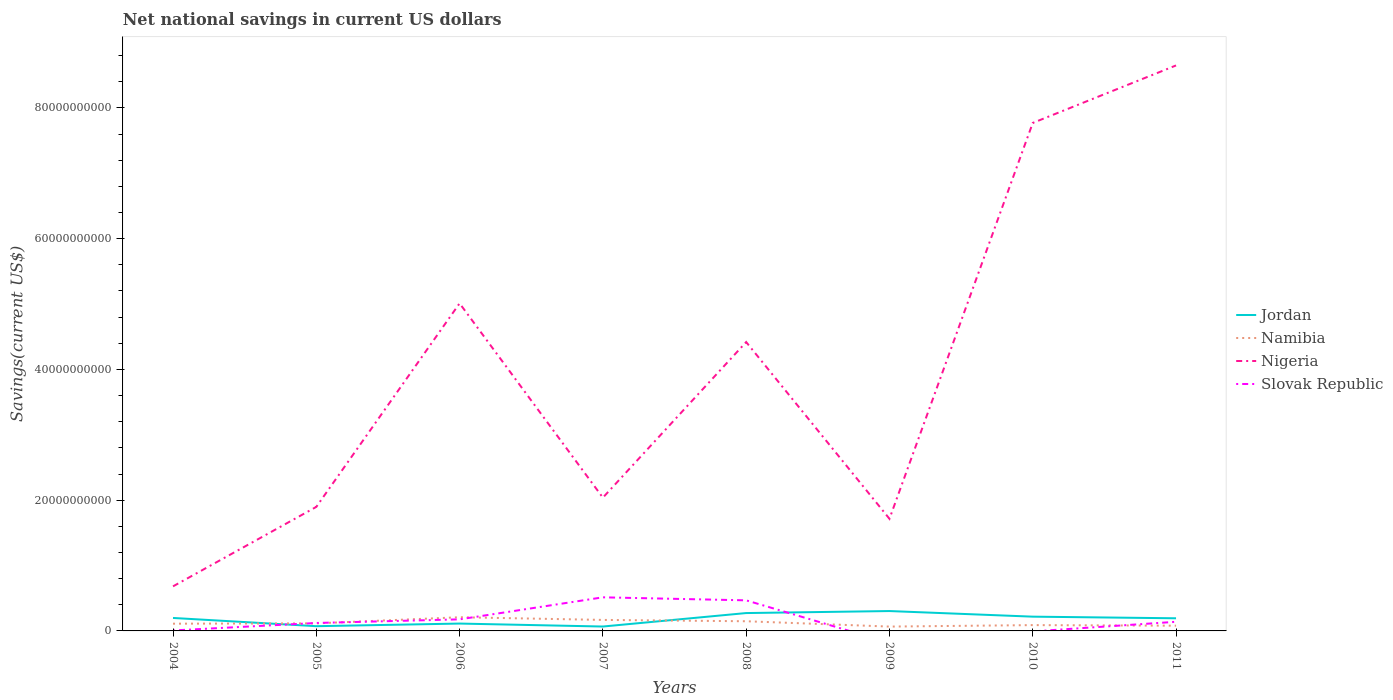Does the line corresponding to Jordan intersect with the line corresponding to Nigeria?
Offer a terse response. No. What is the total net national savings in Namibia in the graph?
Your response must be concise. -4.90e+07. What is the difference between the highest and the second highest net national savings in Slovak Republic?
Your answer should be very brief. 5.14e+09. What is the difference between the highest and the lowest net national savings in Slovak Republic?
Your answer should be very brief. 2. How many lines are there?
Keep it short and to the point. 4. Does the graph contain grids?
Provide a succinct answer. No. Where does the legend appear in the graph?
Provide a succinct answer. Center right. How many legend labels are there?
Keep it short and to the point. 4. How are the legend labels stacked?
Your response must be concise. Vertical. What is the title of the graph?
Offer a terse response. Net national savings in current US dollars. Does "Bahamas" appear as one of the legend labels in the graph?
Your response must be concise. No. What is the label or title of the Y-axis?
Offer a very short reply. Savings(current US$). What is the Savings(current US$) in Jordan in 2004?
Your response must be concise. 1.98e+09. What is the Savings(current US$) in Namibia in 2004?
Your response must be concise. 1.11e+09. What is the Savings(current US$) of Nigeria in 2004?
Your response must be concise. 6.82e+09. What is the Savings(current US$) in Slovak Republic in 2004?
Offer a very short reply. 6.97e+07. What is the Savings(current US$) in Jordan in 2005?
Offer a very short reply. 7.24e+08. What is the Savings(current US$) of Namibia in 2005?
Your answer should be compact. 1.16e+09. What is the Savings(current US$) of Nigeria in 2005?
Your response must be concise. 1.90e+1. What is the Savings(current US$) in Slovak Republic in 2005?
Your answer should be very brief. 1.21e+09. What is the Savings(current US$) in Jordan in 2006?
Your response must be concise. 1.13e+09. What is the Savings(current US$) in Namibia in 2006?
Your answer should be very brief. 2.09e+09. What is the Savings(current US$) in Nigeria in 2006?
Provide a succinct answer. 5.01e+1. What is the Savings(current US$) of Slovak Republic in 2006?
Provide a succinct answer. 1.77e+09. What is the Savings(current US$) of Jordan in 2007?
Offer a terse response. 6.72e+08. What is the Savings(current US$) in Namibia in 2007?
Provide a short and direct response. 1.68e+09. What is the Savings(current US$) in Nigeria in 2007?
Give a very brief answer. 2.04e+1. What is the Savings(current US$) of Slovak Republic in 2007?
Your answer should be very brief. 5.14e+09. What is the Savings(current US$) of Jordan in 2008?
Give a very brief answer. 2.73e+09. What is the Savings(current US$) in Namibia in 2008?
Offer a very short reply. 1.48e+09. What is the Savings(current US$) in Nigeria in 2008?
Provide a short and direct response. 4.42e+1. What is the Savings(current US$) in Slovak Republic in 2008?
Provide a succinct answer. 4.68e+09. What is the Savings(current US$) in Jordan in 2009?
Offer a very short reply. 3.04e+09. What is the Savings(current US$) of Namibia in 2009?
Give a very brief answer. 6.64e+08. What is the Savings(current US$) of Nigeria in 2009?
Offer a very short reply. 1.72e+1. What is the Savings(current US$) of Jordan in 2010?
Ensure brevity in your answer.  2.18e+09. What is the Savings(current US$) of Namibia in 2010?
Offer a terse response. 8.89e+08. What is the Savings(current US$) in Nigeria in 2010?
Your answer should be very brief. 7.77e+1. What is the Savings(current US$) of Jordan in 2011?
Ensure brevity in your answer.  1.93e+09. What is the Savings(current US$) of Namibia in 2011?
Provide a short and direct response. 8.00e+08. What is the Savings(current US$) in Nigeria in 2011?
Your answer should be compact. 8.65e+1. What is the Savings(current US$) in Slovak Republic in 2011?
Keep it short and to the point. 1.40e+09. Across all years, what is the maximum Savings(current US$) in Jordan?
Provide a succinct answer. 3.04e+09. Across all years, what is the maximum Savings(current US$) in Namibia?
Keep it short and to the point. 2.09e+09. Across all years, what is the maximum Savings(current US$) of Nigeria?
Provide a succinct answer. 8.65e+1. Across all years, what is the maximum Savings(current US$) in Slovak Republic?
Offer a terse response. 5.14e+09. Across all years, what is the minimum Savings(current US$) of Jordan?
Ensure brevity in your answer.  6.72e+08. Across all years, what is the minimum Savings(current US$) in Namibia?
Keep it short and to the point. 6.64e+08. Across all years, what is the minimum Savings(current US$) in Nigeria?
Your answer should be very brief. 6.82e+09. Across all years, what is the minimum Savings(current US$) in Slovak Republic?
Ensure brevity in your answer.  0. What is the total Savings(current US$) of Jordan in the graph?
Ensure brevity in your answer.  1.44e+1. What is the total Savings(current US$) in Namibia in the graph?
Ensure brevity in your answer.  9.87e+09. What is the total Savings(current US$) of Nigeria in the graph?
Keep it short and to the point. 3.22e+11. What is the total Savings(current US$) of Slovak Republic in the graph?
Your answer should be compact. 1.43e+1. What is the difference between the Savings(current US$) of Jordan in 2004 and that in 2005?
Your answer should be compact. 1.26e+09. What is the difference between the Savings(current US$) in Namibia in 2004 and that in 2005?
Your answer should be compact. -4.90e+07. What is the difference between the Savings(current US$) of Nigeria in 2004 and that in 2005?
Provide a succinct answer. -1.22e+1. What is the difference between the Savings(current US$) of Slovak Republic in 2004 and that in 2005?
Offer a terse response. -1.14e+09. What is the difference between the Savings(current US$) of Jordan in 2004 and that in 2006?
Keep it short and to the point. 8.58e+08. What is the difference between the Savings(current US$) in Namibia in 2004 and that in 2006?
Provide a short and direct response. -9.87e+08. What is the difference between the Savings(current US$) in Nigeria in 2004 and that in 2006?
Ensure brevity in your answer.  -4.33e+1. What is the difference between the Savings(current US$) in Slovak Republic in 2004 and that in 2006?
Keep it short and to the point. -1.70e+09. What is the difference between the Savings(current US$) in Jordan in 2004 and that in 2007?
Ensure brevity in your answer.  1.31e+09. What is the difference between the Savings(current US$) of Namibia in 2004 and that in 2007?
Keep it short and to the point. -5.77e+08. What is the difference between the Savings(current US$) of Nigeria in 2004 and that in 2007?
Your answer should be compact. -1.36e+1. What is the difference between the Savings(current US$) in Slovak Republic in 2004 and that in 2007?
Ensure brevity in your answer.  -5.07e+09. What is the difference between the Savings(current US$) in Jordan in 2004 and that in 2008?
Your answer should be very brief. -7.50e+08. What is the difference between the Savings(current US$) in Namibia in 2004 and that in 2008?
Your answer should be compact. -3.73e+08. What is the difference between the Savings(current US$) of Nigeria in 2004 and that in 2008?
Give a very brief answer. -3.74e+1. What is the difference between the Savings(current US$) in Slovak Republic in 2004 and that in 2008?
Keep it short and to the point. -4.61e+09. What is the difference between the Savings(current US$) of Jordan in 2004 and that in 2009?
Keep it short and to the point. -1.06e+09. What is the difference between the Savings(current US$) in Namibia in 2004 and that in 2009?
Offer a terse response. 4.42e+08. What is the difference between the Savings(current US$) in Nigeria in 2004 and that in 2009?
Your answer should be very brief. -1.03e+1. What is the difference between the Savings(current US$) of Jordan in 2004 and that in 2010?
Give a very brief answer. -2.00e+08. What is the difference between the Savings(current US$) in Namibia in 2004 and that in 2010?
Provide a short and direct response. 2.17e+08. What is the difference between the Savings(current US$) of Nigeria in 2004 and that in 2010?
Your response must be concise. -7.09e+1. What is the difference between the Savings(current US$) in Jordan in 2004 and that in 2011?
Offer a very short reply. 4.93e+07. What is the difference between the Savings(current US$) of Namibia in 2004 and that in 2011?
Your answer should be very brief. 3.07e+08. What is the difference between the Savings(current US$) in Nigeria in 2004 and that in 2011?
Your response must be concise. -7.97e+1. What is the difference between the Savings(current US$) in Slovak Republic in 2004 and that in 2011?
Make the answer very short. -1.33e+09. What is the difference between the Savings(current US$) of Jordan in 2005 and that in 2006?
Offer a terse response. -4.02e+08. What is the difference between the Savings(current US$) of Namibia in 2005 and that in 2006?
Your answer should be very brief. -9.38e+08. What is the difference between the Savings(current US$) of Nigeria in 2005 and that in 2006?
Make the answer very short. -3.11e+1. What is the difference between the Savings(current US$) in Slovak Republic in 2005 and that in 2006?
Offer a very short reply. -5.56e+08. What is the difference between the Savings(current US$) in Jordan in 2005 and that in 2007?
Offer a terse response. 5.21e+07. What is the difference between the Savings(current US$) in Namibia in 2005 and that in 2007?
Provide a succinct answer. -5.28e+08. What is the difference between the Savings(current US$) in Nigeria in 2005 and that in 2007?
Offer a very short reply. -1.41e+09. What is the difference between the Savings(current US$) in Slovak Republic in 2005 and that in 2007?
Your response must be concise. -3.92e+09. What is the difference between the Savings(current US$) of Jordan in 2005 and that in 2008?
Make the answer very short. -2.01e+09. What is the difference between the Savings(current US$) of Namibia in 2005 and that in 2008?
Provide a succinct answer. -3.24e+08. What is the difference between the Savings(current US$) in Nigeria in 2005 and that in 2008?
Make the answer very short. -2.52e+1. What is the difference between the Savings(current US$) in Slovak Republic in 2005 and that in 2008?
Ensure brevity in your answer.  -3.46e+09. What is the difference between the Savings(current US$) in Jordan in 2005 and that in 2009?
Ensure brevity in your answer.  -2.32e+09. What is the difference between the Savings(current US$) in Namibia in 2005 and that in 2009?
Offer a terse response. 4.91e+08. What is the difference between the Savings(current US$) in Nigeria in 2005 and that in 2009?
Provide a succinct answer. 1.82e+09. What is the difference between the Savings(current US$) in Jordan in 2005 and that in 2010?
Make the answer very short. -1.46e+09. What is the difference between the Savings(current US$) in Namibia in 2005 and that in 2010?
Your response must be concise. 2.66e+08. What is the difference between the Savings(current US$) in Nigeria in 2005 and that in 2010?
Offer a terse response. -5.87e+1. What is the difference between the Savings(current US$) of Jordan in 2005 and that in 2011?
Give a very brief answer. -1.21e+09. What is the difference between the Savings(current US$) in Namibia in 2005 and that in 2011?
Your answer should be compact. 3.56e+08. What is the difference between the Savings(current US$) of Nigeria in 2005 and that in 2011?
Give a very brief answer. -6.75e+1. What is the difference between the Savings(current US$) of Slovak Republic in 2005 and that in 2011?
Your answer should be very brief. -1.83e+08. What is the difference between the Savings(current US$) of Jordan in 2006 and that in 2007?
Your answer should be compact. 4.54e+08. What is the difference between the Savings(current US$) of Namibia in 2006 and that in 2007?
Ensure brevity in your answer.  4.09e+08. What is the difference between the Savings(current US$) in Nigeria in 2006 and that in 2007?
Give a very brief answer. 2.97e+1. What is the difference between the Savings(current US$) of Slovak Republic in 2006 and that in 2007?
Provide a short and direct response. -3.37e+09. What is the difference between the Savings(current US$) of Jordan in 2006 and that in 2008?
Ensure brevity in your answer.  -1.61e+09. What is the difference between the Savings(current US$) in Namibia in 2006 and that in 2008?
Your answer should be very brief. 6.14e+08. What is the difference between the Savings(current US$) in Nigeria in 2006 and that in 2008?
Make the answer very short. 5.92e+09. What is the difference between the Savings(current US$) of Slovak Republic in 2006 and that in 2008?
Ensure brevity in your answer.  -2.91e+09. What is the difference between the Savings(current US$) in Jordan in 2006 and that in 2009?
Your answer should be compact. -1.91e+09. What is the difference between the Savings(current US$) in Namibia in 2006 and that in 2009?
Make the answer very short. 1.43e+09. What is the difference between the Savings(current US$) of Nigeria in 2006 and that in 2009?
Give a very brief answer. 3.30e+1. What is the difference between the Savings(current US$) in Jordan in 2006 and that in 2010?
Ensure brevity in your answer.  -1.06e+09. What is the difference between the Savings(current US$) of Namibia in 2006 and that in 2010?
Give a very brief answer. 1.20e+09. What is the difference between the Savings(current US$) of Nigeria in 2006 and that in 2010?
Provide a succinct answer. -2.76e+1. What is the difference between the Savings(current US$) of Jordan in 2006 and that in 2011?
Your answer should be very brief. -8.08e+08. What is the difference between the Savings(current US$) in Namibia in 2006 and that in 2011?
Offer a very short reply. 1.29e+09. What is the difference between the Savings(current US$) in Nigeria in 2006 and that in 2011?
Ensure brevity in your answer.  -3.64e+1. What is the difference between the Savings(current US$) in Slovak Republic in 2006 and that in 2011?
Your answer should be compact. 3.73e+08. What is the difference between the Savings(current US$) of Jordan in 2007 and that in 2008?
Give a very brief answer. -2.06e+09. What is the difference between the Savings(current US$) in Namibia in 2007 and that in 2008?
Give a very brief answer. 2.05e+08. What is the difference between the Savings(current US$) in Nigeria in 2007 and that in 2008?
Your answer should be compact. -2.38e+1. What is the difference between the Savings(current US$) of Slovak Republic in 2007 and that in 2008?
Offer a terse response. 4.62e+08. What is the difference between the Savings(current US$) of Jordan in 2007 and that in 2009?
Ensure brevity in your answer.  -2.37e+09. What is the difference between the Savings(current US$) in Namibia in 2007 and that in 2009?
Your response must be concise. 1.02e+09. What is the difference between the Savings(current US$) in Nigeria in 2007 and that in 2009?
Ensure brevity in your answer.  3.23e+09. What is the difference between the Savings(current US$) of Jordan in 2007 and that in 2010?
Offer a terse response. -1.51e+09. What is the difference between the Savings(current US$) of Namibia in 2007 and that in 2010?
Give a very brief answer. 7.95e+08. What is the difference between the Savings(current US$) of Nigeria in 2007 and that in 2010?
Give a very brief answer. -5.73e+1. What is the difference between the Savings(current US$) of Jordan in 2007 and that in 2011?
Your response must be concise. -1.26e+09. What is the difference between the Savings(current US$) in Namibia in 2007 and that in 2011?
Your response must be concise. 8.84e+08. What is the difference between the Savings(current US$) in Nigeria in 2007 and that in 2011?
Provide a short and direct response. -6.61e+1. What is the difference between the Savings(current US$) in Slovak Republic in 2007 and that in 2011?
Make the answer very short. 3.74e+09. What is the difference between the Savings(current US$) of Jordan in 2008 and that in 2009?
Your answer should be very brief. -3.08e+08. What is the difference between the Savings(current US$) of Namibia in 2008 and that in 2009?
Keep it short and to the point. 8.15e+08. What is the difference between the Savings(current US$) of Nigeria in 2008 and that in 2009?
Offer a terse response. 2.70e+1. What is the difference between the Savings(current US$) in Jordan in 2008 and that in 2010?
Keep it short and to the point. 5.50e+08. What is the difference between the Savings(current US$) of Namibia in 2008 and that in 2010?
Provide a succinct answer. 5.90e+08. What is the difference between the Savings(current US$) in Nigeria in 2008 and that in 2010?
Provide a short and direct response. -3.35e+1. What is the difference between the Savings(current US$) of Jordan in 2008 and that in 2011?
Provide a succinct answer. 7.99e+08. What is the difference between the Savings(current US$) in Namibia in 2008 and that in 2011?
Provide a short and direct response. 6.80e+08. What is the difference between the Savings(current US$) in Nigeria in 2008 and that in 2011?
Give a very brief answer. -4.23e+1. What is the difference between the Savings(current US$) in Slovak Republic in 2008 and that in 2011?
Ensure brevity in your answer.  3.28e+09. What is the difference between the Savings(current US$) of Jordan in 2009 and that in 2010?
Provide a succinct answer. 8.58e+08. What is the difference between the Savings(current US$) in Namibia in 2009 and that in 2010?
Ensure brevity in your answer.  -2.25e+08. What is the difference between the Savings(current US$) of Nigeria in 2009 and that in 2010?
Offer a very short reply. -6.05e+1. What is the difference between the Savings(current US$) of Jordan in 2009 and that in 2011?
Your answer should be compact. 1.11e+09. What is the difference between the Savings(current US$) of Namibia in 2009 and that in 2011?
Your response must be concise. -1.36e+08. What is the difference between the Savings(current US$) of Nigeria in 2009 and that in 2011?
Give a very brief answer. -6.93e+1. What is the difference between the Savings(current US$) of Jordan in 2010 and that in 2011?
Your answer should be compact. 2.49e+08. What is the difference between the Savings(current US$) of Namibia in 2010 and that in 2011?
Make the answer very short. 8.98e+07. What is the difference between the Savings(current US$) of Nigeria in 2010 and that in 2011?
Provide a short and direct response. -8.80e+09. What is the difference between the Savings(current US$) of Jordan in 2004 and the Savings(current US$) of Namibia in 2005?
Provide a succinct answer. 8.27e+08. What is the difference between the Savings(current US$) of Jordan in 2004 and the Savings(current US$) of Nigeria in 2005?
Provide a short and direct response. -1.70e+1. What is the difference between the Savings(current US$) in Jordan in 2004 and the Savings(current US$) in Slovak Republic in 2005?
Ensure brevity in your answer.  7.68e+08. What is the difference between the Savings(current US$) in Namibia in 2004 and the Savings(current US$) in Nigeria in 2005?
Provide a succinct answer. -1.79e+1. What is the difference between the Savings(current US$) of Namibia in 2004 and the Savings(current US$) of Slovak Republic in 2005?
Keep it short and to the point. -1.08e+08. What is the difference between the Savings(current US$) of Nigeria in 2004 and the Savings(current US$) of Slovak Republic in 2005?
Provide a short and direct response. 5.60e+09. What is the difference between the Savings(current US$) in Jordan in 2004 and the Savings(current US$) in Namibia in 2006?
Your answer should be compact. -1.11e+08. What is the difference between the Savings(current US$) in Jordan in 2004 and the Savings(current US$) in Nigeria in 2006?
Your answer should be compact. -4.81e+1. What is the difference between the Savings(current US$) in Jordan in 2004 and the Savings(current US$) in Slovak Republic in 2006?
Ensure brevity in your answer.  2.12e+08. What is the difference between the Savings(current US$) of Namibia in 2004 and the Savings(current US$) of Nigeria in 2006?
Your answer should be very brief. -4.90e+1. What is the difference between the Savings(current US$) of Namibia in 2004 and the Savings(current US$) of Slovak Republic in 2006?
Keep it short and to the point. -6.65e+08. What is the difference between the Savings(current US$) of Nigeria in 2004 and the Savings(current US$) of Slovak Republic in 2006?
Your response must be concise. 5.05e+09. What is the difference between the Savings(current US$) of Jordan in 2004 and the Savings(current US$) of Namibia in 2007?
Your response must be concise. 2.99e+08. What is the difference between the Savings(current US$) in Jordan in 2004 and the Savings(current US$) in Nigeria in 2007?
Make the answer very short. -1.84e+1. What is the difference between the Savings(current US$) in Jordan in 2004 and the Savings(current US$) in Slovak Republic in 2007?
Offer a very short reply. -3.16e+09. What is the difference between the Savings(current US$) of Namibia in 2004 and the Savings(current US$) of Nigeria in 2007?
Offer a very short reply. -1.93e+1. What is the difference between the Savings(current US$) of Namibia in 2004 and the Savings(current US$) of Slovak Republic in 2007?
Keep it short and to the point. -4.03e+09. What is the difference between the Savings(current US$) of Nigeria in 2004 and the Savings(current US$) of Slovak Republic in 2007?
Make the answer very short. 1.68e+09. What is the difference between the Savings(current US$) in Jordan in 2004 and the Savings(current US$) in Namibia in 2008?
Your answer should be compact. 5.04e+08. What is the difference between the Savings(current US$) in Jordan in 2004 and the Savings(current US$) in Nigeria in 2008?
Provide a short and direct response. -4.22e+1. What is the difference between the Savings(current US$) in Jordan in 2004 and the Savings(current US$) in Slovak Republic in 2008?
Your answer should be very brief. -2.69e+09. What is the difference between the Savings(current US$) in Namibia in 2004 and the Savings(current US$) in Nigeria in 2008?
Your answer should be compact. -4.31e+1. What is the difference between the Savings(current US$) in Namibia in 2004 and the Savings(current US$) in Slovak Republic in 2008?
Give a very brief answer. -3.57e+09. What is the difference between the Savings(current US$) of Nigeria in 2004 and the Savings(current US$) of Slovak Republic in 2008?
Your response must be concise. 2.14e+09. What is the difference between the Savings(current US$) of Jordan in 2004 and the Savings(current US$) of Namibia in 2009?
Ensure brevity in your answer.  1.32e+09. What is the difference between the Savings(current US$) of Jordan in 2004 and the Savings(current US$) of Nigeria in 2009?
Offer a very short reply. -1.52e+1. What is the difference between the Savings(current US$) of Namibia in 2004 and the Savings(current US$) of Nigeria in 2009?
Your response must be concise. -1.60e+1. What is the difference between the Savings(current US$) of Jordan in 2004 and the Savings(current US$) of Namibia in 2010?
Offer a terse response. 1.09e+09. What is the difference between the Savings(current US$) of Jordan in 2004 and the Savings(current US$) of Nigeria in 2010?
Your response must be concise. -7.57e+1. What is the difference between the Savings(current US$) in Namibia in 2004 and the Savings(current US$) in Nigeria in 2010?
Keep it short and to the point. -7.66e+1. What is the difference between the Savings(current US$) of Jordan in 2004 and the Savings(current US$) of Namibia in 2011?
Your answer should be compact. 1.18e+09. What is the difference between the Savings(current US$) of Jordan in 2004 and the Savings(current US$) of Nigeria in 2011?
Make the answer very short. -8.45e+1. What is the difference between the Savings(current US$) in Jordan in 2004 and the Savings(current US$) in Slovak Republic in 2011?
Offer a terse response. 5.85e+08. What is the difference between the Savings(current US$) in Namibia in 2004 and the Savings(current US$) in Nigeria in 2011?
Ensure brevity in your answer.  -8.54e+1. What is the difference between the Savings(current US$) of Namibia in 2004 and the Savings(current US$) of Slovak Republic in 2011?
Provide a succinct answer. -2.91e+08. What is the difference between the Savings(current US$) in Nigeria in 2004 and the Savings(current US$) in Slovak Republic in 2011?
Your answer should be compact. 5.42e+09. What is the difference between the Savings(current US$) in Jordan in 2005 and the Savings(current US$) in Namibia in 2006?
Give a very brief answer. -1.37e+09. What is the difference between the Savings(current US$) in Jordan in 2005 and the Savings(current US$) in Nigeria in 2006?
Keep it short and to the point. -4.94e+1. What is the difference between the Savings(current US$) in Jordan in 2005 and the Savings(current US$) in Slovak Republic in 2006?
Provide a short and direct response. -1.05e+09. What is the difference between the Savings(current US$) of Namibia in 2005 and the Savings(current US$) of Nigeria in 2006?
Offer a very short reply. -4.89e+1. What is the difference between the Savings(current US$) in Namibia in 2005 and the Savings(current US$) in Slovak Republic in 2006?
Provide a short and direct response. -6.16e+08. What is the difference between the Savings(current US$) in Nigeria in 2005 and the Savings(current US$) in Slovak Republic in 2006?
Offer a very short reply. 1.72e+1. What is the difference between the Savings(current US$) in Jordan in 2005 and the Savings(current US$) in Namibia in 2007?
Keep it short and to the point. -9.60e+08. What is the difference between the Savings(current US$) of Jordan in 2005 and the Savings(current US$) of Nigeria in 2007?
Keep it short and to the point. -1.97e+1. What is the difference between the Savings(current US$) in Jordan in 2005 and the Savings(current US$) in Slovak Republic in 2007?
Offer a very short reply. -4.42e+09. What is the difference between the Savings(current US$) in Namibia in 2005 and the Savings(current US$) in Nigeria in 2007?
Provide a succinct answer. -1.92e+1. What is the difference between the Savings(current US$) in Namibia in 2005 and the Savings(current US$) in Slovak Republic in 2007?
Provide a succinct answer. -3.98e+09. What is the difference between the Savings(current US$) of Nigeria in 2005 and the Savings(current US$) of Slovak Republic in 2007?
Your answer should be very brief. 1.38e+1. What is the difference between the Savings(current US$) in Jordan in 2005 and the Savings(current US$) in Namibia in 2008?
Give a very brief answer. -7.55e+08. What is the difference between the Savings(current US$) of Jordan in 2005 and the Savings(current US$) of Nigeria in 2008?
Your answer should be compact. -4.35e+1. What is the difference between the Savings(current US$) of Jordan in 2005 and the Savings(current US$) of Slovak Republic in 2008?
Offer a terse response. -3.95e+09. What is the difference between the Savings(current US$) in Namibia in 2005 and the Savings(current US$) in Nigeria in 2008?
Keep it short and to the point. -4.30e+1. What is the difference between the Savings(current US$) of Namibia in 2005 and the Savings(current US$) of Slovak Republic in 2008?
Offer a terse response. -3.52e+09. What is the difference between the Savings(current US$) in Nigeria in 2005 and the Savings(current US$) in Slovak Republic in 2008?
Provide a short and direct response. 1.43e+1. What is the difference between the Savings(current US$) in Jordan in 2005 and the Savings(current US$) in Namibia in 2009?
Offer a very short reply. 5.97e+07. What is the difference between the Savings(current US$) of Jordan in 2005 and the Savings(current US$) of Nigeria in 2009?
Offer a very short reply. -1.64e+1. What is the difference between the Savings(current US$) of Namibia in 2005 and the Savings(current US$) of Nigeria in 2009?
Ensure brevity in your answer.  -1.60e+1. What is the difference between the Savings(current US$) in Jordan in 2005 and the Savings(current US$) in Namibia in 2010?
Your response must be concise. -1.66e+08. What is the difference between the Savings(current US$) of Jordan in 2005 and the Savings(current US$) of Nigeria in 2010?
Provide a short and direct response. -7.70e+1. What is the difference between the Savings(current US$) of Namibia in 2005 and the Savings(current US$) of Nigeria in 2010?
Make the answer very short. -7.65e+1. What is the difference between the Savings(current US$) in Jordan in 2005 and the Savings(current US$) in Namibia in 2011?
Your answer should be compact. -7.59e+07. What is the difference between the Savings(current US$) of Jordan in 2005 and the Savings(current US$) of Nigeria in 2011?
Provide a short and direct response. -8.58e+1. What is the difference between the Savings(current US$) of Jordan in 2005 and the Savings(current US$) of Slovak Republic in 2011?
Provide a succinct answer. -6.74e+08. What is the difference between the Savings(current US$) of Namibia in 2005 and the Savings(current US$) of Nigeria in 2011?
Offer a terse response. -8.53e+1. What is the difference between the Savings(current US$) of Namibia in 2005 and the Savings(current US$) of Slovak Republic in 2011?
Keep it short and to the point. -2.42e+08. What is the difference between the Savings(current US$) in Nigeria in 2005 and the Savings(current US$) in Slovak Republic in 2011?
Offer a terse response. 1.76e+1. What is the difference between the Savings(current US$) in Jordan in 2006 and the Savings(current US$) in Namibia in 2007?
Keep it short and to the point. -5.59e+08. What is the difference between the Savings(current US$) in Jordan in 2006 and the Savings(current US$) in Nigeria in 2007?
Make the answer very short. -1.93e+1. What is the difference between the Savings(current US$) of Jordan in 2006 and the Savings(current US$) of Slovak Republic in 2007?
Your response must be concise. -4.01e+09. What is the difference between the Savings(current US$) in Namibia in 2006 and the Savings(current US$) in Nigeria in 2007?
Keep it short and to the point. -1.83e+1. What is the difference between the Savings(current US$) of Namibia in 2006 and the Savings(current US$) of Slovak Republic in 2007?
Your response must be concise. -3.05e+09. What is the difference between the Savings(current US$) of Nigeria in 2006 and the Savings(current US$) of Slovak Republic in 2007?
Your response must be concise. 4.50e+1. What is the difference between the Savings(current US$) of Jordan in 2006 and the Savings(current US$) of Namibia in 2008?
Offer a terse response. -3.54e+08. What is the difference between the Savings(current US$) of Jordan in 2006 and the Savings(current US$) of Nigeria in 2008?
Your response must be concise. -4.31e+1. What is the difference between the Savings(current US$) in Jordan in 2006 and the Savings(current US$) in Slovak Republic in 2008?
Make the answer very short. -3.55e+09. What is the difference between the Savings(current US$) in Namibia in 2006 and the Savings(current US$) in Nigeria in 2008?
Your answer should be compact. -4.21e+1. What is the difference between the Savings(current US$) in Namibia in 2006 and the Savings(current US$) in Slovak Republic in 2008?
Your answer should be very brief. -2.58e+09. What is the difference between the Savings(current US$) in Nigeria in 2006 and the Savings(current US$) in Slovak Republic in 2008?
Offer a very short reply. 4.54e+1. What is the difference between the Savings(current US$) in Jordan in 2006 and the Savings(current US$) in Namibia in 2009?
Make the answer very short. 4.61e+08. What is the difference between the Savings(current US$) in Jordan in 2006 and the Savings(current US$) in Nigeria in 2009?
Your response must be concise. -1.60e+1. What is the difference between the Savings(current US$) of Namibia in 2006 and the Savings(current US$) of Nigeria in 2009?
Your answer should be compact. -1.51e+1. What is the difference between the Savings(current US$) of Jordan in 2006 and the Savings(current US$) of Namibia in 2010?
Offer a very short reply. 2.36e+08. What is the difference between the Savings(current US$) in Jordan in 2006 and the Savings(current US$) in Nigeria in 2010?
Provide a succinct answer. -7.66e+1. What is the difference between the Savings(current US$) in Namibia in 2006 and the Savings(current US$) in Nigeria in 2010?
Provide a short and direct response. -7.56e+1. What is the difference between the Savings(current US$) of Jordan in 2006 and the Savings(current US$) of Namibia in 2011?
Provide a short and direct response. 3.26e+08. What is the difference between the Savings(current US$) of Jordan in 2006 and the Savings(current US$) of Nigeria in 2011?
Your answer should be very brief. -8.54e+1. What is the difference between the Savings(current US$) in Jordan in 2006 and the Savings(current US$) in Slovak Republic in 2011?
Your answer should be compact. -2.72e+08. What is the difference between the Savings(current US$) of Namibia in 2006 and the Savings(current US$) of Nigeria in 2011?
Provide a succinct answer. -8.44e+1. What is the difference between the Savings(current US$) in Namibia in 2006 and the Savings(current US$) in Slovak Republic in 2011?
Your response must be concise. 6.96e+08. What is the difference between the Savings(current US$) of Nigeria in 2006 and the Savings(current US$) of Slovak Republic in 2011?
Give a very brief answer. 4.87e+1. What is the difference between the Savings(current US$) of Jordan in 2007 and the Savings(current US$) of Namibia in 2008?
Provide a short and direct response. -8.08e+08. What is the difference between the Savings(current US$) of Jordan in 2007 and the Savings(current US$) of Nigeria in 2008?
Your answer should be compact. -4.35e+1. What is the difference between the Savings(current US$) of Jordan in 2007 and the Savings(current US$) of Slovak Republic in 2008?
Your answer should be compact. -4.01e+09. What is the difference between the Savings(current US$) in Namibia in 2007 and the Savings(current US$) in Nigeria in 2008?
Provide a succinct answer. -4.25e+1. What is the difference between the Savings(current US$) of Namibia in 2007 and the Savings(current US$) of Slovak Republic in 2008?
Give a very brief answer. -2.99e+09. What is the difference between the Savings(current US$) in Nigeria in 2007 and the Savings(current US$) in Slovak Republic in 2008?
Offer a terse response. 1.57e+1. What is the difference between the Savings(current US$) in Jordan in 2007 and the Savings(current US$) in Namibia in 2009?
Your answer should be very brief. 7.56e+06. What is the difference between the Savings(current US$) in Jordan in 2007 and the Savings(current US$) in Nigeria in 2009?
Offer a very short reply. -1.65e+1. What is the difference between the Savings(current US$) of Namibia in 2007 and the Savings(current US$) of Nigeria in 2009?
Make the answer very short. -1.55e+1. What is the difference between the Savings(current US$) in Jordan in 2007 and the Savings(current US$) in Namibia in 2010?
Keep it short and to the point. -2.18e+08. What is the difference between the Savings(current US$) in Jordan in 2007 and the Savings(current US$) in Nigeria in 2010?
Your answer should be very brief. -7.70e+1. What is the difference between the Savings(current US$) in Namibia in 2007 and the Savings(current US$) in Nigeria in 2010?
Give a very brief answer. -7.60e+1. What is the difference between the Savings(current US$) in Jordan in 2007 and the Savings(current US$) in Namibia in 2011?
Ensure brevity in your answer.  -1.28e+08. What is the difference between the Savings(current US$) of Jordan in 2007 and the Savings(current US$) of Nigeria in 2011?
Ensure brevity in your answer.  -8.58e+1. What is the difference between the Savings(current US$) of Jordan in 2007 and the Savings(current US$) of Slovak Republic in 2011?
Ensure brevity in your answer.  -7.26e+08. What is the difference between the Savings(current US$) of Namibia in 2007 and the Savings(current US$) of Nigeria in 2011?
Your answer should be very brief. -8.48e+1. What is the difference between the Savings(current US$) in Namibia in 2007 and the Savings(current US$) in Slovak Republic in 2011?
Your answer should be very brief. 2.86e+08. What is the difference between the Savings(current US$) in Nigeria in 2007 and the Savings(current US$) in Slovak Republic in 2011?
Give a very brief answer. 1.90e+1. What is the difference between the Savings(current US$) of Jordan in 2008 and the Savings(current US$) of Namibia in 2009?
Offer a terse response. 2.07e+09. What is the difference between the Savings(current US$) in Jordan in 2008 and the Savings(current US$) in Nigeria in 2009?
Your answer should be compact. -1.44e+1. What is the difference between the Savings(current US$) of Namibia in 2008 and the Savings(current US$) of Nigeria in 2009?
Offer a very short reply. -1.57e+1. What is the difference between the Savings(current US$) of Jordan in 2008 and the Savings(current US$) of Namibia in 2010?
Ensure brevity in your answer.  1.84e+09. What is the difference between the Savings(current US$) in Jordan in 2008 and the Savings(current US$) in Nigeria in 2010?
Your response must be concise. -7.50e+1. What is the difference between the Savings(current US$) in Namibia in 2008 and the Savings(current US$) in Nigeria in 2010?
Provide a succinct answer. -7.62e+1. What is the difference between the Savings(current US$) in Jordan in 2008 and the Savings(current US$) in Namibia in 2011?
Keep it short and to the point. 1.93e+09. What is the difference between the Savings(current US$) of Jordan in 2008 and the Savings(current US$) of Nigeria in 2011?
Make the answer very short. -8.38e+1. What is the difference between the Savings(current US$) in Jordan in 2008 and the Savings(current US$) in Slovak Republic in 2011?
Keep it short and to the point. 1.33e+09. What is the difference between the Savings(current US$) in Namibia in 2008 and the Savings(current US$) in Nigeria in 2011?
Make the answer very short. -8.50e+1. What is the difference between the Savings(current US$) in Namibia in 2008 and the Savings(current US$) in Slovak Republic in 2011?
Your answer should be compact. 8.14e+07. What is the difference between the Savings(current US$) in Nigeria in 2008 and the Savings(current US$) in Slovak Republic in 2011?
Keep it short and to the point. 4.28e+1. What is the difference between the Savings(current US$) of Jordan in 2009 and the Savings(current US$) of Namibia in 2010?
Your answer should be compact. 2.15e+09. What is the difference between the Savings(current US$) of Jordan in 2009 and the Savings(current US$) of Nigeria in 2010?
Your answer should be compact. -7.47e+1. What is the difference between the Savings(current US$) in Namibia in 2009 and the Savings(current US$) in Nigeria in 2010?
Provide a succinct answer. -7.70e+1. What is the difference between the Savings(current US$) of Jordan in 2009 and the Savings(current US$) of Namibia in 2011?
Provide a succinct answer. 2.24e+09. What is the difference between the Savings(current US$) of Jordan in 2009 and the Savings(current US$) of Nigeria in 2011?
Your answer should be compact. -8.35e+1. What is the difference between the Savings(current US$) in Jordan in 2009 and the Savings(current US$) in Slovak Republic in 2011?
Your answer should be very brief. 1.64e+09. What is the difference between the Savings(current US$) in Namibia in 2009 and the Savings(current US$) in Nigeria in 2011?
Ensure brevity in your answer.  -8.58e+1. What is the difference between the Savings(current US$) in Namibia in 2009 and the Savings(current US$) in Slovak Republic in 2011?
Make the answer very short. -7.34e+08. What is the difference between the Savings(current US$) of Nigeria in 2009 and the Savings(current US$) of Slovak Republic in 2011?
Provide a short and direct response. 1.58e+1. What is the difference between the Savings(current US$) of Jordan in 2010 and the Savings(current US$) of Namibia in 2011?
Ensure brevity in your answer.  1.38e+09. What is the difference between the Savings(current US$) of Jordan in 2010 and the Savings(current US$) of Nigeria in 2011?
Keep it short and to the point. -8.43e+1. What is the difference between the Savings(current US$) in Jordan in 2010 and the Savings(current US$) in Slovak Republic in 2011?
Provide a short and direct response. 7.85e+08. What is the difference between the Savings(current US$) in Namibia in 2010 and the Savings(current US$) in Nigeria in 2011?
Your answer should be compact. -8.56e+1. What is the difference between the Savings(current US$) in Namibia in 2010 and the Savings(current US$) in Slovak Republic in 2011?
Ensure brevity in your answer.  -5.08e+08. What is the difference between the Savings(current US$) in Nigeria in 2010 and the Savings(current US$) in Slovak Republic in 2011?
Offer a very short reply. 7.63e+1. What is the average Savings(current US$) of Jordan per year?
Keep it short and to the point. 1.80e+09. What is the average Savings(current US$) in Namibia per year?
Ensure brevity in your answer.  1.23e+09. What is the average Savings(current US$) in Nigeria per year?
Keep it short and to the point. 4.02e+1. What is the average Savings(current US$) of Slovak Republic per year?
Ensure brevity in your answer.  1.78e+09. In the year 2004, what is the difference between the Savings(current US$) of Jordan and Savings(current US$) of Namibia?
Your answer should be very brief. 8.76e+08. In the year 2004, what is the difference between the Savings(current US$) in Jordan and Savings(current US$) in Nigeria?
Give a very brief answer. -4.83e+09. In the year 2004, what is the difference between the Savings(current US$) in Jordan and Savings(current US$) in Slovak Republic?
Keep it short and to the point. 1.91e+09. In the year 2004, what is the difference between the Savings(current US$) of Namibia and Savings(current US$) of Nigeria?
Keep it short and to the point. -5.71e+09. In the year 2004, what is the difference between the Savings(current US$) in Namibia and Savings(current US$) in Slovak Republic?
Provide a short and direct response. 1.04e+09. In the year 2004, what is the difference between the Savings(current US$) in Nigeria and Savings(current US$) in Slovak Republic?
Provide a short and direct response. 6.75e+09. In the year 2005, what is the difference between the Savings(current US$) in Jordan and Savings(current US$) in Namibia?
Offer a terse response. -4.32e+08. In the year 2005, what is the difference between the Savings(current US$) of Jordan and Savings(current US$) of Nigeria?
Your answer should be very brief. -1.82e+1. In the year 2005, what is the difference between the Savings(current US$) in Jordan and Savings(current US$) in Slovak Republic?
Ensure brevity in your answer.  -4.91e+08. In the year 2005, what is the difference between the Savings(current US$) in Namibia and Savings(current US$) in Nigeria?
Give a very brief answer. -1.78e+1. In the year 2005, what is the difference between the Savings(current US$) of Namibia and Savings(current US$) of Slovak Republic?
Give a very brief answer. -5.92e+07. In the year 2005, what is the difference between the Savings(current US$) of Nigeria and Savings(current US$) of Slovak Republic?
Offer a terse response. 1.78e+1. In the year 2006, what is the difference between the Savings(current US$) in Jordan and Savings(current US$) in Namibia?
Give a very brief answer. -9.68e+08. In the year 2006, what is the difference between the Savings(current US$) in Jordan and Savings(current US$) in Nigeria?
Provide a short and direct response. -4.90e+1. In the year 2006, what is the difference between the Savings(current US$) in Jordan and Savings(current US$) in Slovak Republic?
Ensure brevity in your answer.  -6.46e+08. In the year 2006, what is the difference between the Savings(current US$) in Namibia and Savings(current US$) in Nigeria?
Your response must be concise. -4.80e+1. In the year 2006, what is the difference between the Savings(current US$) of Namibia and Savings(current US$) of Slovak Republic?
Ensure brevity in your answer.  3.22e+08. In the year 2006, what is the difference between the Savings(current US$) of Nigeria and Savings(current US$) of Slovak Republic?
Offer a very short reply. 4.83e+1. In the year 2007, what is the difference between the Savings(current US$) of Jordan and Savings(current US$) of Namibia?
Your response must be concise. -1.01e+09. In the year 2007, what is the difference between the Savings(current US$) of Jordan and Savings(current US$) of Nigeria?
Your answer should be very brief. -1.97e+1. In the year 2007, what is the difference between the Savings(current US$) in Jordan and Savings(current US$) in Slovak Republic?
Ensure brevity in your answer.  -4.47e+09. In the year 2007, what is the difference between the Savings(current US$) of Namibia and Savings(current US$) of Nigeria?
Give a very brief answer. -1.87e+1. In the year 2007, what is the difference between the Savings(current US$) of Namibia and Savings(current US$) of Slovak Republic?
Offer a terse response. -3.46e+09. In the year 2007, what is the difference between the Savings(current US$) in Nigeria and Savings(current US$) in Slovak Republic?
Make the answer very short. 1.52e+1. In the year 2008, what is the difference between the Savings(current US$) of Jordan and Savings(current US$) of Namibia?
Offer a very short reply. 1.25e+09. In the year 2008, what is the difference between the Savings(current US$) of Jordan and Savings(current US$) of Nigeria?
Your response must be concise. -4.15e+1. In the year 2008, what is the difference between the Savings(current US$) of Jordan and Savings(current US$) of Slovak Republic?
Your response must be concise. -1.95e+09. In the year 2008, what is the difference between the Savings(current US$) of Namibia and Savings(current US$) of Nigeria?
Offer a very short reply. -4.27e+1. In the year 2008, what is the difference between the Savings(current US$) of Namibia and Savings(current US$) of Slovak Republic?
Make the answer very short. -3.20e+09. In the year 2008, what is the difference between the Savings(current US$) in Nigeria and Savings(current US$) in Slovak Republic?
Give a very brief answer. 3.95e+1. In the year 2009, what is the difference between the Savings(current US$) of Jordan and Savings(current US$) of Namibia?
Provide a succinct answer. 2.38e+09. In the year 2009, what is the difference between the Savings(current US$) of Jordan and Savings(current US$) of Nigeria?
Provide a succinct answer. -1.41e+1. In the year 2009, what is the difference between the Savings(current US$) of Namibia and Savings(current US$) of Nigeria?
Provide a succinct answer. -1.65e+1. In the year 2010, what is the difference between the Savings(current US$) in Jordan and Savings(current US$) in Namibia?
Keep it short and to the point. 1.29e+09. In the year 2010, what is the difference between the Savings(current US$) of Jordan and Savings(current US$) of Nigeria?
Your response must be concise. -7.55e+1. In the year 2010, what is the difference between the Savings(current US$) of Namibia and Savings(current US$) of Nigeria?
Provide a short and direct response. -7.68e+1. In the year 2011, what is the difference between the Savings(current US$) of Jordan and Savings(current US$) of Namibia?
Give a very brief answer. 1.13e+09. In the year 2011, what is the difference between the Savings(current US$) in Jordan and Savings(current US$) in Nigeria?
Offer a very short reply. -8.46e+1. In the year 2011, what is the difference between the Savings(current US$) of Jordan and Savings(current US$) of Slovak Republic?
Make the answer very short. 5.36e+08. In the year 2011, what is the difference between the Savings(current US$) in Namibia and Savings(current US$) in Nigeria?
Your answer should be very brief. -8.57e+1. In the year 2011, what is the difference between the Savings(current US$) of Namibia and Savings(current US$) of Slovak Republic?
Give a very brief answer. -5.98e+08. In the year 2011, what is the difference between the Savings(current US$) of Nigeria and Savings(current US$) of Slovak Republic?
Your response must be concise. 8.51e+1. What is the ratio of the Savings(current US$) of Jordan in 2004 to that in 2005?
Make the answer very short. 2.74. What is the ratio of the Savings(current US$) in Namibia in 2004 to that in 2005?
Offer a terse response. 0.96. What is the ratio of the Savings(current US$) of Nigeria in 2004 to that in 2005?
Make the answer very short. 0.36. What is the ratio of the Savings(current US$) in Slovak Republic in 2004 to that in 2005?
Make the answer very short. 0.06. What is the ratio of the Savings(current US$) in Jordan in 2004 to that in 2006?
Make the answer very short. 1.76. What is the ratio of the Savings(current US$) in Namibia in 2004 to that in 2006?
Keep it short and to the point. 0.53. What is the ratio of the Savings(current US$) in Nigeria in 2004 to that in 2006?
Keep it short and to the point. 0.14. What is the ratio of the Savings(current US$) in Slovak Republic in 2004 to that in 2006?
Your answer should be compact. 0.04. What is the ratio of the Savings(current US$) of Jordan in 2004 to that in 2007?
Your response must be concise. 2.95. What is the ratio of the Savings(current US$) of Namibia in 2004 to that in 2007?
Provide a succinct answer. 0.66. What is the ratio of the Savings(current US$) of Nigeria in 2004 to that in 2007?
Give a very brief answer. 0.33. What is the ratio of the Savings(current US$) in Slovak Republic in 2004 to that in 2007?
Your answer should be compact. 0.01. What is the ratio of the Savings(current US$) of Jordan in 2004 to that in 2008?
Make the answer very short. 0.73. What is the ratio of the Savings(current US$) of Namibia in 2004 to that in 2008?
Provide a short and direct response. 0.75. What is the ratio of the Savings(current US$) in Nigeria in 2004 to that in 2008?
Provide a short and direct response. 0.15. What is the ratio of the Savings(current US$) in Slovak Republic in 2004 to that in 2008?
Your answer should be very brief. 0.01. What is the ratio of the Savings(current US$) in Jordan in 2004 to that in 2009?
Provide a succinct answer. 0.65. What is the ratio of the Savings(current US$) of Namibia in 2004 to that in 2009?
Your response must be concise. 1.67. What is the ratio of the Savings(current US$) of Nigeria in 2004 to that in 2009?
Your answer should be very brief. 0.4. What is the ratio of the Savings(current US$) in Jordan in 2004 to that in 2010?
Make the answer very short. 0.91. What is the ratio of the Savings(current US$) of Namibia in 2004 to that in 2010?
Keep it short and to the point. 1.24. What is the ratio of the Savings(current US$) of Nigeria in 2004 to that in 2010?
Offer a terse response. 0.09. What is the ratio of the Savings(current US$) of Jordan in 2004 to that in 2011?
Your response must be concise. 1.03. What is the ratio of the Savings(current US$) in Namibia in 2004 to that in 2011?
Offer a terse response. 1.38. What is the ratio of the Savings(current US$) of Nigeria in 2004 to that in 2011?
Make the answer very short. 0.08. What is the ratio of the Savings(current US$) of Slovak Republic in 2004 to that in 2011?
Your answer should be very brief. 0.05. What is the ratio of the Savings(current US$) in Jordan in 2005 to that in 2006?
Ensure brevity in your answer.  0.64. What is the ratio of the Savings(current US$) of Namibia in 2005 to that in 2006?
Offer a very short reply. 0.55. What is the ratio of the Savings(current US$) in Nigeria in 2005 to that in 2006?
Provide a short and direct response. 0.38. What is the ratio of the Savings(current US$) of Slovak Republic in 2005 to that in 2006?
Give a very brief answer. 0.69. What is the ratio of the Savings(current US$) in Jordan in 2005 to that in 2007?
Your response must be concise. 1.08. What is the ratio of the Savings(current US$) of Namibia in 2005 to that in 2007?
Make the answer very short. 0.69. What is the ratio of the Savings(current US$) in Nigeria in 2005 to that in 2007?
Keep it short and to the point. 0.93. What is the ratio of the Savings(current US$) of Slovak Republic in 2005 to that in 2007?
Give a very brief answer. 0.24. What is the ratio of the Savings(current US$) in Jordan in 2005 to that in 2008?
Ensure brevity in your answer.  0.26. What is the ratio of the Savings(current US$) of Namibia in 2005 to that in 2008?
Ensure brevity in your answer.  0.78. What is the ratio of the Savings(current US$) in Nigeria in 2005 to that in 2008?
Give a very brief answer. 0.43. What is the ratio of the Savings(current US$) of Slovak Republic in 2005 to that in 2008?
Ensure brevity in your answer.  0.26. What is the ratio of the Savings(current US$) in Jordan in 2005 to that in 2009?
Your response must be concise. 0.24. What is the ratio of the Savings(current US$) in Namibia in 2005 to that in 2009?
Provide a short and direct response. 1.74. What is the ratio of the Savings(current US$) of Nigeria in 2005 to that in 2009?
Provide a succinct answer. 1.11. What is the ratio of the Savings(current US$) of Jordan in 2005 to that in 2010?
Provide a short and direct response. 0.33. What is the ratio of the Savings(current US$) of Namibia in 2005 to that in 2010?
Offer a very short reply. 1.3. What is the ratio of the Savings(current US$) of Nigeria in 2005 to that in 2010?
Your answer should be very brief. 0.24. What is the ratio of the Savings(current US$) of Jordan in 2005 to that in 2011?
Ensure brevity in your answer.  0.37. What is the ratio of the Savings(current US$) in Namibia in 2005 to that in 2011?
Provide a succinct answer. 1.45. What is the ratio of the Savings(current US$) of Nigeria in 2005 to that in 2011?
Your response must be concise. 0.22. What is the ratio of the Savings(current US$) of Slovak Republic in 2005 to that in 2011?
Your answer should be very brief. 0.87. What is the ratio of the Savings(current US$) of Jordan in 2006 to that in 2007?
Keep it short and to the point. 1.68. What is the ratio of the Savings(current US$) in Namibia in 2006 to that in 2007?
Your answer should be very brief. 1.24. What is the ratio of the Savings(current US$) of Nigeria in 2006 to that in 2007?
Offer a very short reply. 2.46. What is the ratio of the Savings(current US$) of Slovak Republic in 2006 to that in 2007?
Offer a very short reply. 0.34. What is the ratio of the Savings(current US$) in Jordan in 2006 to that in 2008?
Provide a succinct answer. 0.41. What is the ratio of the Savings(current US$) of Namibia in 2006 to that in 2008?
Ensure brevity in your answer.  1.42. What is the ratio of the Savings(current US$) of Nigeria in 2006 to that in 2008?
Offer a very short reply. 1.13. What is the ratio of the Savings(current US$) in Slovak Republic in 2006 to that in 2008?
Ensure brevity in your answer.  0.38. What is the ratio of the Savings(current US$) in Jordan in 2006 to that in 2009?
Your answer should be compact. 0.37. What is the ratio of the Savings(current US$) in Namibia in 2006 to that in 2009?
Provide a succinct answer. 3.15. What is the ratio of the Savings(current US$) in Nigeria in 2006 to that in 2009?
Offer a very short reply. 2.92. What is the ratio of the Savings(current US$) of Jordan in 2006 to that in 2010?
Provide a succinct answer. 0.52. What is the ratio of the Savings(current US$) in Namibia in 2006 to that in 2010?
Offer a terse response. 2.35. What is the ratio of the Savings(current US$) in Nigeria in 2006 to that in 2010?
Your response must be concise. 0.64. What is the ratio of the Savings(current US$) in Jordan in 2006 to that in 2011?
Your response must be concise. 0.58. What is the ratio of the Savings(current US$) in Namibia in 2006 to that in 2011?
Offer a terse response. 2.62. What is the ratio of the Savings(current US$) of Nigeria in 2006 to that in 2011?
Your answer should be very brief. 0.58. What is the ratio of the Savings(current US$) in Slovak Republic in 2006 to that in 2011?
Offer a very short reply. 1.27. What is the ratio of the Savings(current US$) in Jordan in 2007 to that in 2008?
Your answer should be very brief. 0.25. What is the ratio of the Savings(current US$) of Namibia in 2007 to that in 2008?
Make the answer very short. 1.14. What is the ratio of the Savings(current US$) of Nigeria in 2007 to that in 2008?
Keep it short and to the point. 0.46. What is the ratio of the Savings(current US$) of Slovak Republic in 2007 to that in 2008?
Offer a very short reply. 1.1. What is the ratio of the Savings(current US$) in Jordan in 2007 to that in 2009?
Your answer should be compact. 0.22. What is the ratio of the Savings(current US$) of Namibia in 2007 to that in 2009?
Make the answer very short. 2.54. What is the ratio of the Savings(current US$) of Nigeria in 2007 to that in 2009?
Your response must be concise. 1.19. What is the ratio of the Savings(current US$) in Jordan in 2007 to that in 2010?
Keep it short and to the point. 0.31. What is the ratio of the Savings(current US$) of Namibia in 2007 to that in 2010?
Keep it short and to the point. 1.89. What is the ratio of the Savings(current US$) in Nigeria in 2007 to that in 2010?
Your answer should be compact. 0.26. What is the ratio of the Savings(current US$) of Jordan in 2007 to that in 2011?
Keep it short and to the point. 0.35. What is the ratio of the Savings(current US$) of Namibia in 2007 to that in 2011?
Your response must be concise. 2.11. What is the ratio of the Savings(current US$) in Nigeria in 2007 to that in 2011?
Give a very brief answer. 0.24. What is the ratio of the Savings(current US$) of Slovak Republic in 2007 to that in 2011?
Your response must be concise. 3.68. What is the ratio of the Savings(current US$) of Jordan in 2008 to that in 2009?
Ensure brevity in your answer.  0.9. What is the ratio of the Savings(current US$) in Namibia in 2008 to that in 2009?
Offer a very short reply. 2.23. What is the ratio of the Savings(current US$) of Nigeria in 2008 to that in 2009?
Offer a terse response. 2.58. What is the ratio of the Savings(current US$) of Jordan in 2008 to that in 2010?
Offer a terse response. 1.25. What is the ratio of the Savings(current US$) in Namibia in 2008 to that in 2010?
Give a very brief answer. 1.66. What is the ratio of the Savings(current US$) of Nigeria in 2008 to that in 2010?
Offer a terse response. 0.57. What is the ratio of the Savings(current US$) in Jordan in 2008 to that in 2011?
Offer a terse response. 1.41. What is the ratio of the Savings(current US$) of Namibia in 2008 to that in 2011?
Offer a very short reply. 1.85. What is the ratio of the Savings(current US$) of Nigeria in 2008 to that in 2011?
Your response must be concise. 0.51. What is the ratio of the Savings(current US$) of Slovak Republic in 2008 to that in 2011?
Offer a very short reply. 3.35. What is the ratio of the Savings(current US$) of Jordan in 2009 to that in 2010?
Your answer should be compact. 1.39. What is the ratio of the Savings(current US$) in Namibia in 2009 to that in 2010?
Offer a terse response. 0.75. What is the ratio of the Savings(current US$) in Nigeria in 2009 to that in 2010?
Provide a succinct answer. 0.22. What is the ratio of the Savings(current US$) of Jordan in 2009 to that in 2011?
Your response must be concise. 1.57. What is the ratio of the Savings(current US$) in Namibia in 2009 to that in 2011?
Provide a short and direct response. 0.83. What is the ratio of the Savings(current US$) in Nigeria in 2009 to that in 2011?
Provide a short and direct response. 0.2. What is the ratio of the Savings(current US$) in Jordan in 2010 to that in 2011?
Give a very brief answer. 1.13. What is the ratio of the Savings(current US$) of Namibia in 2010 to that in 2011?
Offer a terse response. 1.11. What is the ratio of the Savings(current US$) of Nigeria in 2010 to that in 2011?
Provide a succinct answer. 0.9. What is the difference between the highest and the second highest Savings(current US$) of Jordan?
Offer a terse response. 3.08e+08. What is the difference between the highest and the second highest Savings(current US$) of Namibia?
Your answer should be compact. 4.09e+08. What is the difference between the highest and the second highest Savings(current US$) of Nigeria?
Make the answer very short. 8.80e+09. What is the difference between the highest and the second highest Savings(current US$) of Slovak Republic?
Ensure brevity in your answer.  4.62e+08. What is the difference between the highest and the lowest Savings(current US$) in Jordan?
Your response must be concise. 2.37e+09. What is the difference between the highest and the lowest Savings(current US$) of Namibia?
Your answer should be compact. 1.43e+09. What is the difference between the highest and the lowest Savings(current US$) of Nigeria?
Make the answer very short. 7.97e+1. What is the difference between the highest and the lowest Savings(current US$) of Slovak Republic?
Keep it short and to the point. 5.14e+09. 